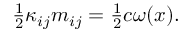<formula> <loc_0><loc_0><loc_500><loc_500>\begin{array} { r } { \frac { 1 } { 2 } \kappa _ { i j } m _ { i j } = \frac { 1 } { 2 } c \omega ( x ) . } \end{array}</formula> 